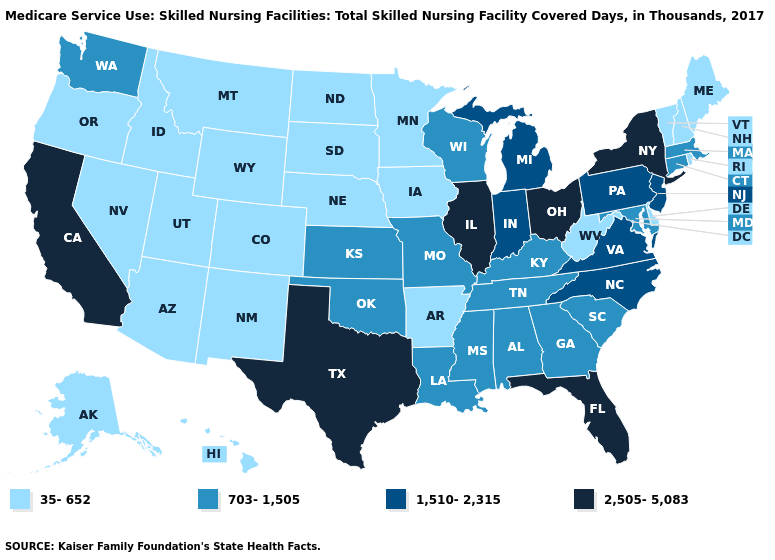Does Indiana have the lowest value in the MidWest?
Quick response, please. No. Does Delaware have the lowest value in the South?
Quick response, please. Yes. Does New York have the highest value in the Northeast?
Answer briefly. Yes. What is the value of Kentucky?
Be succinct. 703-1,505. Which states have the lowest value in the MidWest?
Give a very brief answer. Iowa, Minnesota, Nebraska, North Dakota, South Dakota. What is the value of Iowa?
Give a very brief answer. 35-652. Name the states that have a value in the range 1,510-2,315?
Give a very brief answer. Indiana, Michigan, New Jersey, North Carolina, Pennsylvania, Virginia. Does Michigan have the lowest value in the USA?
Quick response, please. No. Does Alabama have a higher value than Massachusetts?
Write a very short answer. No. Name the states that have a value in the range 703-1,505?
Give a very brief answer. Alabama, Connecticut, Georgia, Kansas, Kentucky, Louisiana, Maryland, Massachusetts, Mississippi, Missouri, Oklahoma, South Carolina, Tennessee, Washington, Wisconsin. Is the legend a continuous bar?
Quick response, please. No. Which states have the lowest value in the USA?
Short answer required. Alaska, Arizona, Arkansas, Colorado, Delaware, Hawaii, Idaho, Iowa, Maine, Minnesota, Montana, Nebraska, Nevada, New Hampshire, New Mexico, North Dakota, Oregon, Rhode Island, South Dakota, Utah, Vermont, West Virginia, Wyoming. What is the value of Wyoming?
Short answer required. 35-652. What is the value of Nevada?
Write a very short answer. 35-652. What is the value of North Dakota?
Short answer required. 35-652. 